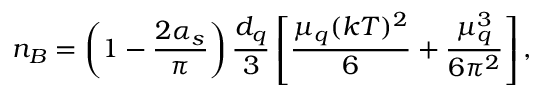<formula> <loc_0><loc_0><loc_500><loc_500>n _ { B } = \left ( 1 - \frac { 2 \alpha _ { s } } { \pi } \right ) \frac { d _ { q } } { 3 } \left [ \frac { \mu _ { q } ( k T ) ^ { 2 } } { 6 } + \frac { \mu _ { q } ^ { 3 } } { 6 \pi ^ { 2 } } \right ] ,</formula> 